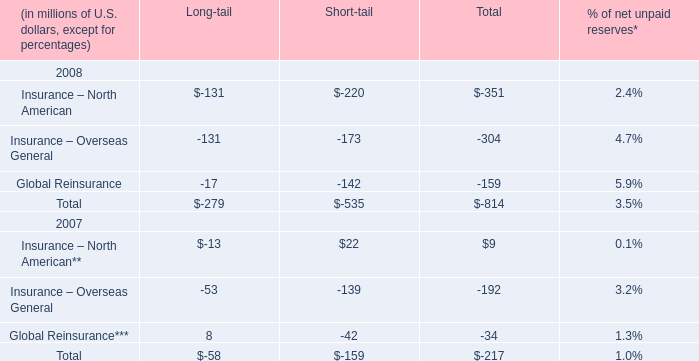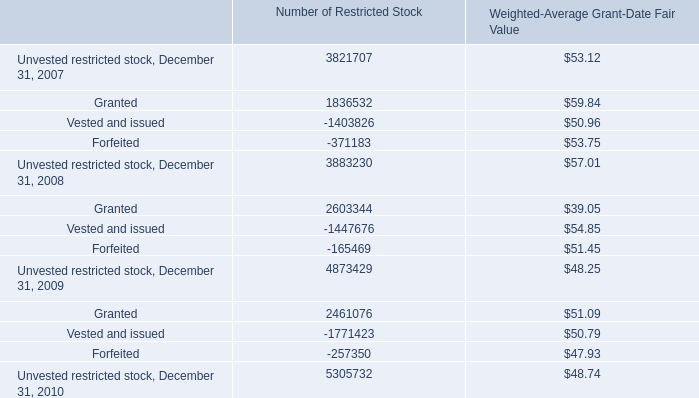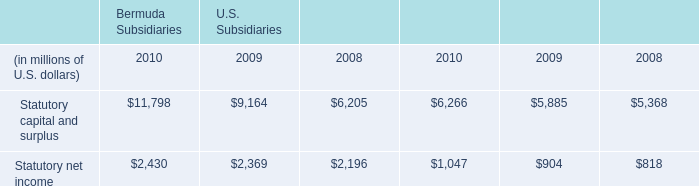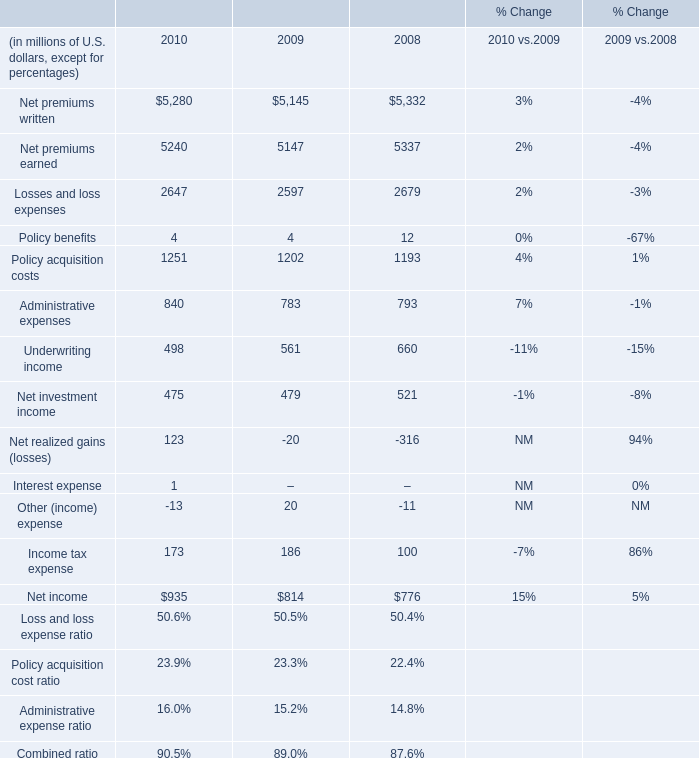What's the total amount of the Total for Long-tail in the years where Net premiums written is greater than 5300? (in million) 
Computations: ((-131 - 131) - 17)
Answer: -279.0. 